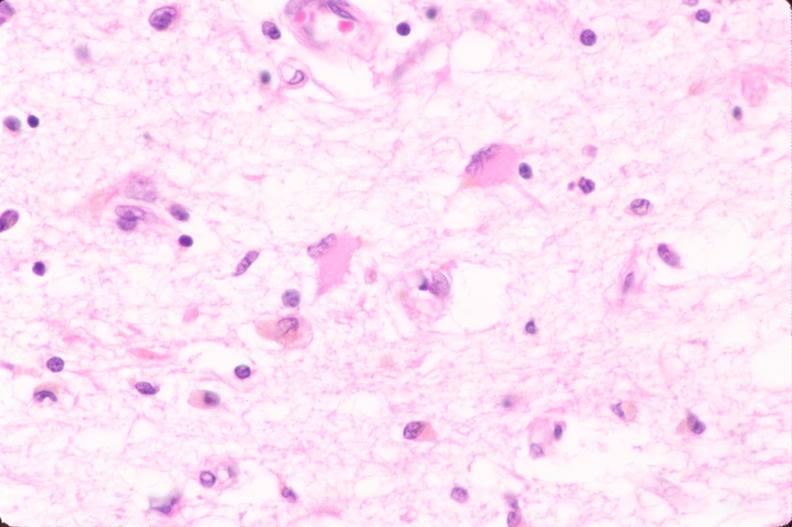does this image show brain, infarct due to ruptured saccular aneurysm and thrombosis of right middle cerebral artery, plasmacytic astrocytes?
Answer the question using a single word or phrase. Yes 